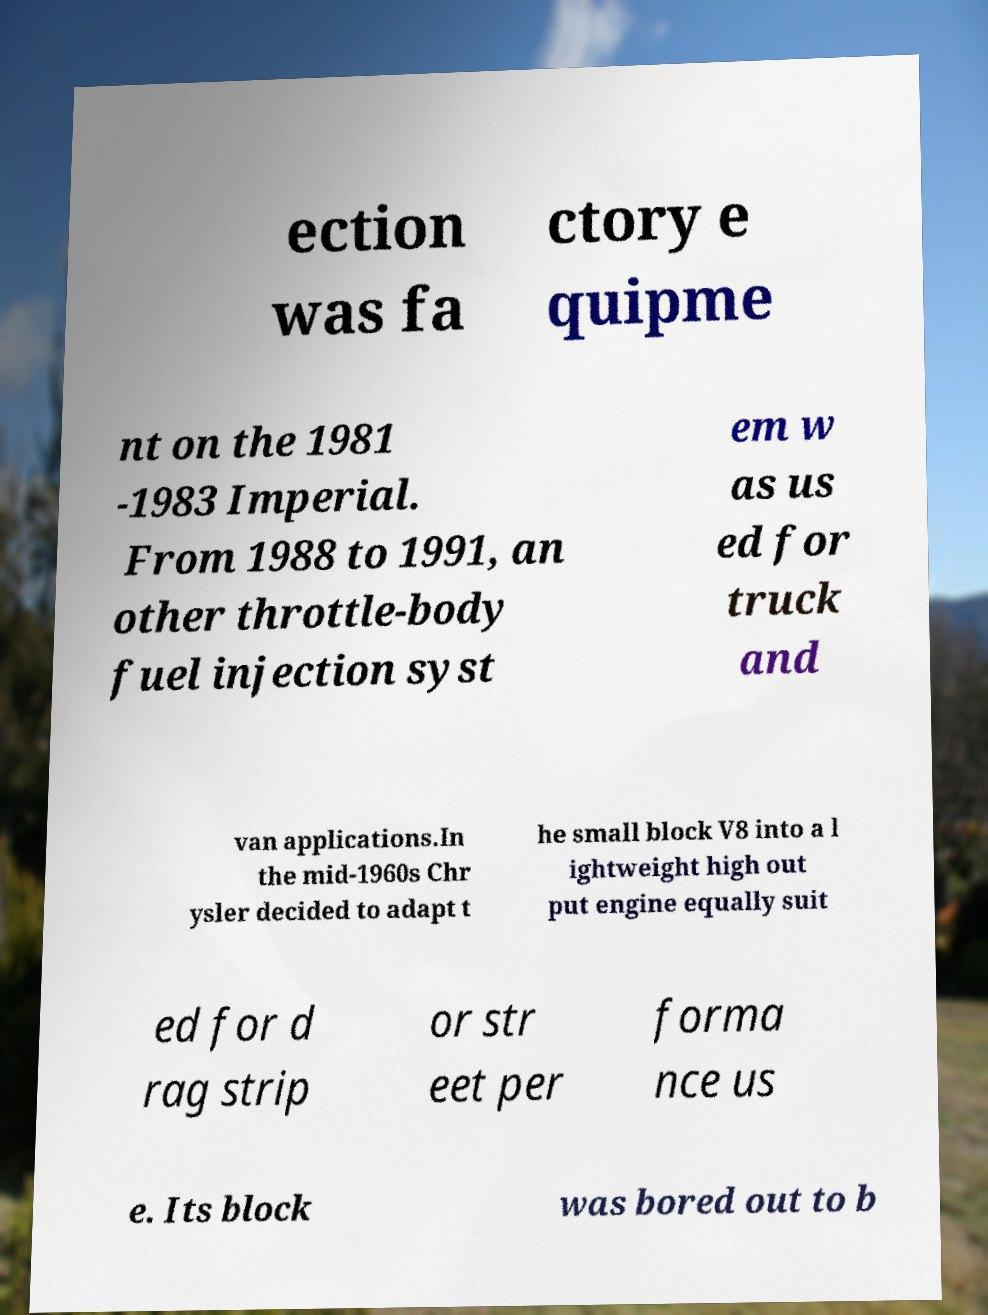Can you read and provide the text displayed in the image?This photo seems to have some interesting text. Can you extract and type it out for me? ection was fa ctory e quipme nt on the 1981 -1983 Imperial. From 1988 to 1991, an other throttle-body fuel injection syst em w as us ed for truck and van applications.In the mid-1960s Chr ysler decided to adapt t he small block V8 into a l ightweight high out put engine equally suit ed for d rag strip or str eet per forma nce us e. Its block was bored out to b 